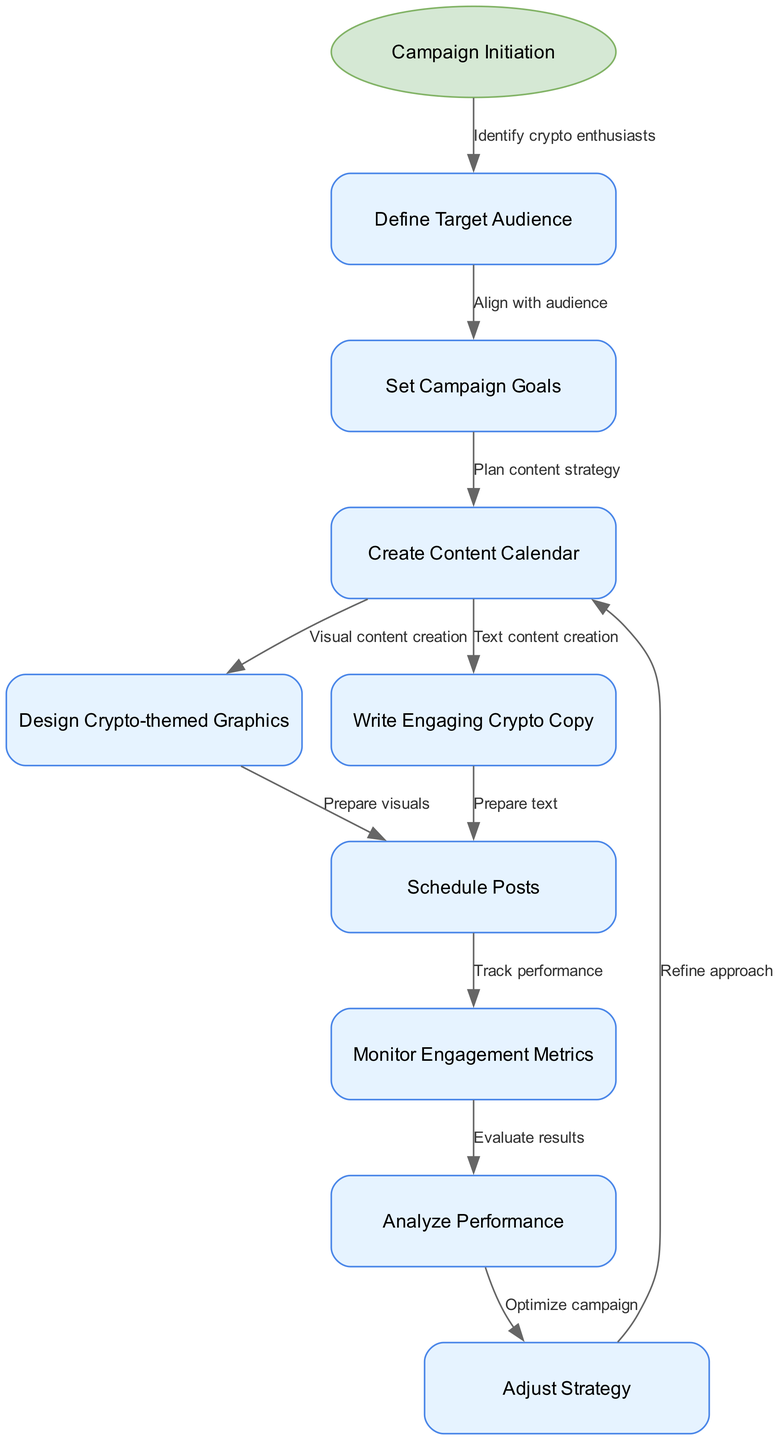What is the starting node of the workflow? The starting node is labeled "Campaign Initiation," which signifies the beginning of the automated social media marketing campaign process.
Answer: Campaign Initiation How many nodes are there in the diagram? The diagram features 10 nodes including the starting node, indicating the various stages involved in the campaign workflow.
Answer: 10 What is the label for the edge from "Define Target Audience" to "Set Campaign Goals"? The label between these nodes reads "Align with audience," which describes the intention of that step in the workflow.
Answer: Align with audience Which node comes directly after "Schedule Posts"? The node that follows "Schedule Posts" is "Monitor Engagement Metrics," which indicates the next step in assessing the posts' performance.
Answer: Monitor Engagement Metrics What is the last action in the workflow before refining the approach? The last action before refining the approach is "Analyze Performance," which involves evaluating the effectiveness of the campaign before making adjustments.
Answer: Analyze Performance What relationship does "Create Content Calendar" have with "Write Engaging Crypto Copy"? The relationship is that both nodes are actions stemming from "Create Content Calendar," where one focuses on text content creation while the other focuses on visual content creation to support the campaign.
Answer: Plan content strategy How does the process return to the "Create Content Calendar"? After completing the "Adjust Strategy" step, the workflow loops back to "Create Content Calendar" for refining the approach based on previous learnings and performance evaluations.
Answer: Refine approach What step follows the "Monitor Engagement Metrics"? The subsequent step is "Analyze Performance," indicating a transition from tracking metrics to performing a more detailed analysis of the campaign.
Answer: Analyze Performance What type of campaign does this workflow focus on? The workflow specifically emphasizes an "Automated social media marketing campaign," tailored to enhance brand awareness in the cryptocurrency space.
Answer: Automated social media marketing campaign 